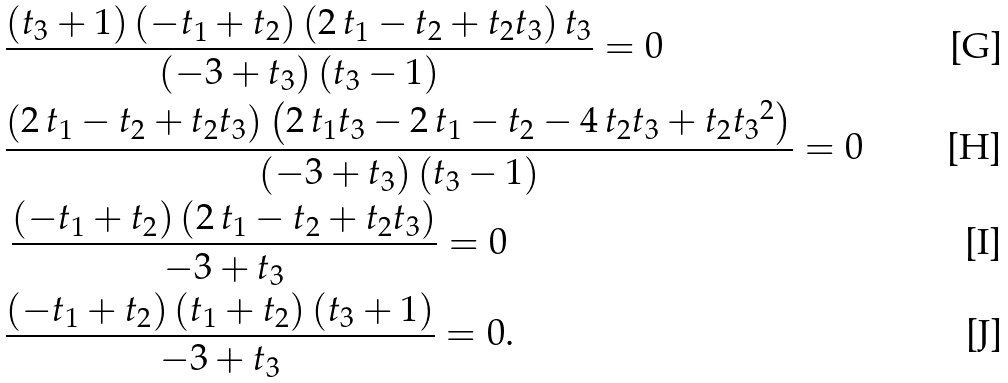Convert formula to latex. <formula><loc_0><loc_0><loc_500><loc_500>& { \frac { \left ( t _ { 3 } + 1 \right ) \left ( - t _ { 1 } + t _ { 2 } \right ) \left ( 2 \, t _ { 1 } - t _ { 2 } + t _ { 2 } t _ { 3 } \right ) t _ { 3 } } { \left ( - 3 + t _ { 3 } \right ) \left ( t _ { 3 } - 1 \right ) } } = 0 \\ & { \frac { \left ( 2 \, t _ { 1 } - t _ { 2 } + t _ { 2 } t _ { 3 } \right ) \left ( 2 \, t _ { 1 } t _ { 3 } - 2 \, t _ { 1 } - t _ { 2 } - 4 \, t _ { 2 } t _ { 3 } + t _ { 2 } { t _ { 3 } } ^ { 2 } \right ) } { \left ( - 3 + t _ { 3 } \right ) \left ( t _ { 3 } - 1 \right ) } } = 0 \\ & \, { \frac { \left ( - t _ { 1 } + t _ { 2 } \right ) \left ( 2 \, t _ { 1 } - t _ { 2 } + t _ { 2 } t _ { 3 } \right ) } { - 3 + t _ { 3 } } } = 0 \\ & { \frac { \left ( - t _ { 1 } + t _ { 2 } \right ) \left ( t _ { 1 } + t _ { 2 } \right ) \left ( t _ { 3 } + 1 \right ) } { - 3 + t _ { 3 } } } = 0 .</formula> 